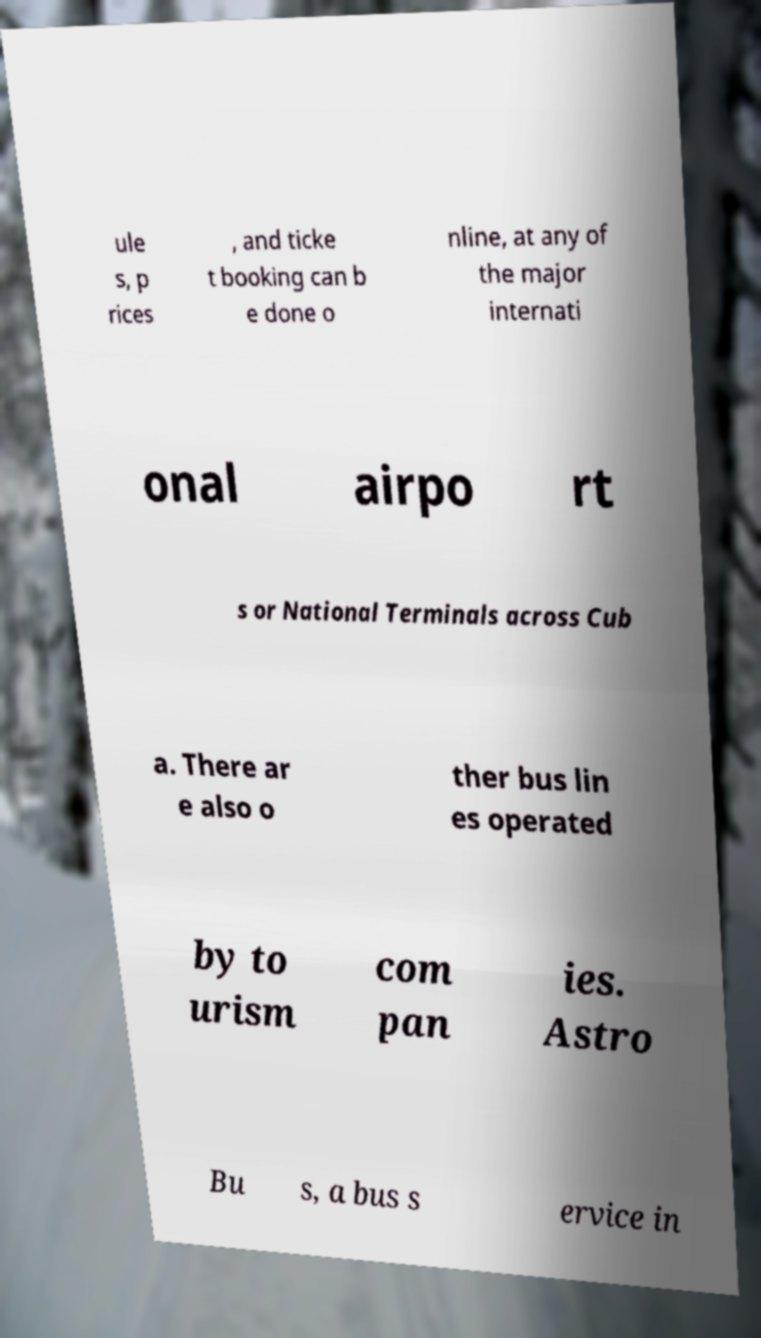For documentation purposes, I need the text within this image transcribed. Could you provide that? ule s, p rices , and ticke t booking can b e done o nline, at any of the major internati onal airpo rt s or National Terminals across Cub a. There ar e also o ther bus lin es operated by to urism com pan ies. Astro Bu s, a bus s ervice in 